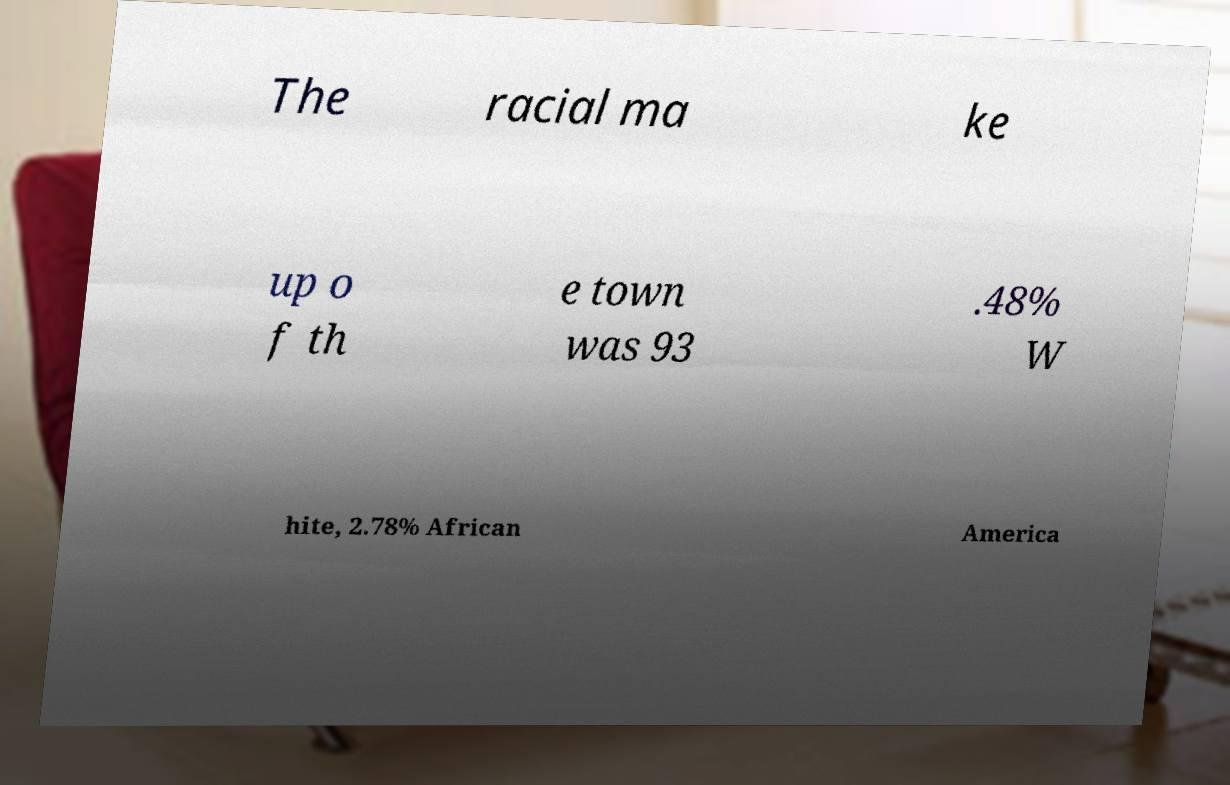I need the written content from this picture converted into text. Can you do that? The racial ma ke up o f th e town was 93 .48% W hite, 2.78% African America 